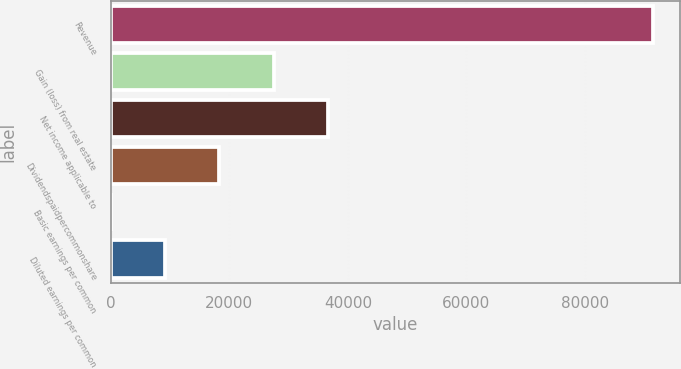<chart> <loc_0><loc_0><loc_500><loc_500><bar_chart><fcel>Revenue<fcel>Gain (loss) from real estate<fcel>Net income applicable to<fcel>Dividendspaidpercommonshare<fcel>Basic earnings per common<fcel>Diluted earnings per common<nl><fcel>91508<fcel>27452.5<fcel>36603.3<fcel>18301.7<fcel>0.17<fcel>9150.95<nl></chart> 